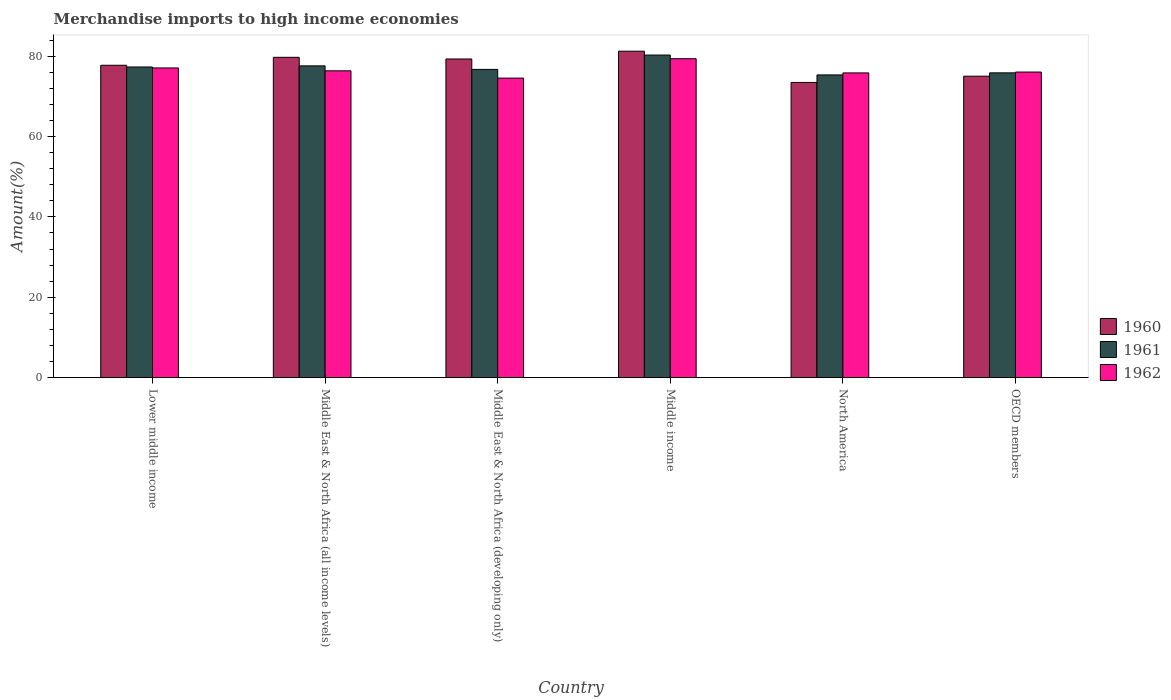How many bars are there on the 3rd tick from the left?
Your answer should be compact. 3. What is the label of the 3rd group of bars from the left?
Make the answer very short. Middle East & North Africa (developing only). In how many cases, is the number of bars for a given country not equal to the number of legend labels?
Your response must be concise. 0. What is the percentage of amount earned from merchandise imports in 1962 in North America?
Make the answer very short. 75.82. Across all countries, what is the maximum percentage of amount earned from merchandise imports in 1961?
Provide a short and direct response. 80.27. Across all countries, what is the minimum percentage of amount earned from merchandise imports in 1960?
Make the answer very short. 73.45. In which country was the percentage of amount earned from merchandise imports in 1960 maximum?
Your answer should be compact. Middle income. What is the total percentage of amount earned from merchandise imports in 1962 in the graph?
Your answer should be compact. 459.16. What is the difference between the percentage of amount earned from merchandise imports in 1961 in Middle East & North Africa (developing only) and that in Middle income?
Your answer should be very brief. -3.57. What is the difference between the percentage of amount earned from merchandise imports in 1962 in OECD members and the percentage of amount earned from merchandise imports in 1960 in Lower middle income?
Keep it short and to the point. -1.69. What is the average percentage of amount earned from merchandise imports in 1962 per country?
Offer a terse response. 76.53. What is the difference between the percentage of amount earned from merchandise imports of/in 1962 and percentage of amount earned from merchandise imports of/in 1961 in Middle income?
Your response must be concise. -0.91. What is the ratio of the percentage of amount earned from merchandise imports in 1962 in Lower middle income to that in Middle East & North Africa (all income levels)?
Offer a very short reply. 1.01. Is the percentage of amount earned from merchandise imports in 1960 in Middle income less than that in North America?
Give a very brief answer. No. Is the difference between the percentage of amount earned from merchandise imports in 1962 in Lower middle income and Middle East & North Africa (developing only) greater than the difference between the percentage of amount earned from merchandise imports in 1961 in Lower middle income and Middle East & North Africa (developing only)?
Offer a terse response. Yes. What is the difference between the highest and the second highest percentage of amount earned from merchandise imports in 1961?
Your response must be concise. 2.97. What is the difference between the highest and the lowest percentage of amount earned from merchandise imports in 1962?
Your response must be concise. 4.83. What does the 1st bar from the left in Middle income represents?
Your response must be concise. 1960. Is it the case that in every country, the sum of the percentage of amount earned from merchandise imports in 1961 and percentage of amount earned from merchandise imports in 1960 is greater than the percentage of amount earned from merchandise imports in 1962?
Ensure brevity in your answer.  Yes. How many countries are there in the graph?
Provide a short and direct response. 6. What is the difference between two consecutive major ticks on the Y-axis?
Your answer should be very brief. 20. Does the graph contain any zero values?
Keep it short and to the point. No. Where does the legend appear in the graph?
Provide a short and direct response. Center right. What is the title of the graph?
Give a very brief answer. Merchandise imports to high income economies. Does "2012" appear as one of the legend labels in the graph?
Your answer should be very brief. No. What is the label or title of the X-axis?
Provide a succinct answer. Country. What is the label or title of the Y-axis?
Keep it short and to the point. Amount(%). What is the Amount(%) in 1960 in Lower middle income?
Provide a succinct answer. 77.73. What is the Amount(%) in 1961 in Lower middle income?
Offer a very short reply. 77.3. What is the Amount(%) in 1962 in Lower middle income?
Your response must be concise. 77.06. What is the Amount(%) of 1960 in Middle East & North Africa (all income levels)?
Keep it short and to the point. 79.7. What is the Amount(%) of 1961 in Middle East & North Africa (all income levels)?
Make the answer very short. 77.58. What is the Amount(%) of 1962 in Middle East & North Africa (all income levels)?
Offer a very short reply. 76.35. What is the Amount(%) of 1960 in Middle East & North Africa (developing only)?
Provide a short and direct response. 79.29. What is the Amount(%) of 1961 in Middle East & North Africa (developing only)?
Your response must be concise. 76.7. What is the Amount(%) in 1962 in Middle East & North Africa (developing only)?
Your answer should be compact. 74.53. What is the Amount(%) in 1960 in Middle income?
Ensure brevity in your answer.  81.23. What is the Amount(%) in 1961 in Middle income?
Give a very brief answer. 80.27. What is the Amount(%) of 1962 in Middle income?
Your response must be concise. 79.36. What is the Amount(%) in 1960 in North America?
Provide a succinct answer. 73.45. What is the Amount(%) in 1961 in North America?
Provide a short and direct response. 75.33. What is the Amount(%) of 1962 in North America?
Provide a short and direct response. 75.82. What is the Amount(%) of 1960 in OECD members?
Offer a very short reply. 75.01. What is the Amount(%) in 1961 in OECD members?
Provide a succinct answer. 75.84. What is the Amount(%) of 1962 in OECD members?
Your response must be concise. 76.04. Across all countries, what is the maximum Amount(%) in 1960?
Keep it short and to the point. 81.23. Across all countries, what is the maximum Amount(%) of 1961?
Keep it short and to the point. 80.27. Across all countries, what is the maximum Amount(%) of 1962?
Ensure brevity in your answer.  79.36. Across all countries, what is the minimum Amount(%) of 1960?
Offer a very short reply. 73.45. Across all countries, what is the minimum Amount(%) of 1961?
Offer a terse response. 75.33. Across all countries, what is the minimum Amount(%) in 1962?
Offer a very short reply. 74.53. What is the total Amount(%) of 1960 in the graph?
Keep it short and to the point. 466.41. What is the total Amount(%) in 1961 in the graph?
Your answer should be compact. 463.01. What is the total Amount(%) in 1962 in the graph?
Make the answer very short. 459.16. What is the difference between the Amount(%) of 1960 in Lower middle income and that in Middle East & North Africa (all income levels)?
Keep it short and to the point. -1.98. What is the difference between the Amount(%) in 1961 in Lower middle income and that in Middle East & North Africa (all income levels)?
Keep it short and to the point. -0.28. What is the difference between the Amount(%) in 1962 in Lower middle income and that in Middle East & North Africa (all income levels)?
Ensure brevity in your answer.  0.72. What is the difference between the Amount(%) of 1960 in Lower middle income and that in Middle East & North Africa (developing only)?
Your response must be concise. -1.57. What is the difference between the Amount(%) of 1961 in Lower middle income and that in Middle East & North Africa (developing only)?
Provide a short and direct response. 0.6. What is the difference between the Amount(%) in 1962 in Lower middle income and that in Middle East & North Africa (developing only)?
Ensure brevity in your answer.  2.53. What is the difference between the Amount(%) of 1960 in Lower middle income and that in Middle income?
Your answer should be very brief. -3.5. What is the difference between the Amount(%) in 1961 in Lower middle income and that in Middle income?
Your response must be concise. -2.97. What is the difference between the Amount(%) in 1962 in Lower middle income and that in Middle income?
Offer a very short reply. -2.3. What is the difference between the Amount(%) in 1960 in Lower middle income and that in North America?
Your response must be concise. 4.27. What is the difference between the Amount(%) in 1961 in Lower middle income and that in North America?
Provide a short and direct response. 1.97. What is the difference between the Amount(%) in 1962 in Lower middle income and that in North America?
Your response must be concise. 1.24. What is the difference between the Amount(%) in 1960 in Lower middle income and that in OECD members?
Offer a terse response. 2.72. What is the difference between the Amount(%) in 1961 in Lower middle income and that in OECD members?
Your response must be concise. 1.46. What is the difference between the Amount(%) of 1962 in Lower middle income and that in OECD members?
Ensure brevity in your answer.  1.02. What is the difference between the Amount(%) in 1960 in Middle East & North Africa (all income levels) and that in Middle East & North Africa (developing only)?
Give a very brief answer. 0.41. What is the difference between the Amount(%) in 1961 in Middle East & North Africa (all income levels) and that in Middle East & North Africa (developing only)?
Your answer should be compact. 0.88. What is the difference between the Amount(%) of 1962 in Middle East & North Africa (all income levels) and that in Middle East & North Africa (developing only)?
Provide a short and direct response. 1.81. What is the difference between the Amount(%) in 1960 in Middle East & North Africa (all income levels) and that in Middle income?
Make the answer very short. -1.52. What is the difference between the Amount(%) in 1961 in Middle East & North Africa (all income levels) and that in Middle income?
Offer a very short reply. -2.69. What is the difference between the Amount(%) of 1962 in Middle East & North Africa (all income levels) and that in Middle income?
Provide a succinct answer. -3.01. What is the difference between the Amount(%) in 1960 in Middle East & North Africa (all income levels) and that in North America?
Your answer should be compact. 6.25. What is the difference between the Amount(%) of 1961 in Middle East & North Africa (all income levels) and that in North America?
Keep it short and to the point. 2.25. What is the difference between the Amount(%) of 1962 in Middle East & North Africa (all income levels) and that in North America?
Ensure brevity in your answer.  0.52. What is the difference between the Amount(%) in 1960 in Middle East & North Africa (all income levels) and that in OECD members?
Give a very brief answer. 4.69. What is the difference between the Amount(%) in 1961 in Middle East & North Africa (all income levels) and that in OECD members?
Give a very brief answer. 1.74. What is the difference between the Amount(%) in 1962 in Middle East & North Africa (all income levels) and that in OECD members?
Give a very brief answer. 0.31. What is the difference between the Amount(%) of 1960 in Middle East & North Africa (developing only) and that in Middle income?
Give a very brief answer. -1.94. What is the difference between the Amount(%) of 1961 in Middle East & North Africa (developing only) and that in Middle income?
Offer a very short reply. -3.57. What is the difference between the Amount(%) of 1962 in Middle East & North Africa (developing only) and that in Middle income?
Make the answer very short. -4.83. What is the difference between the Amount(%) in 1960 in Middle East & North Africa (developing only) and that in North America?
Your response must be concise. 5.84. What is the difference between the Amount(%) in 1961 in Middle East & North Africa (developing only) and that in North America?
Your answer should be compact. 1.37. What is the difference between the Amount(%) of 1962 in Middle East & North Africa (developing only) and that in North America?
Offer a terse response. -1.29. What is the difference between the Amount(%) of 1960 in Middle East & North Africa (developing only) and that in OECD members?
Offer a very short reply. 4.28. What is the difference between the Amount(%) of 1961 in Middle East & North Africa (developing only) and that in OECD members?
Ensure brevity in your answer.  0.86. What is the difference between the Amount(%) in 1962 in Middle East & North Africa (developing only) and that in OECD members?
Make the answer very short. -1.51. What is the difference between the Amount(%) of 1960 in Middle income and that in North America?
Your answer should be compact. 7.77. What is the difference between the Amount(%) in 1961 in Middle income and that in North America?
Offer a very short reply. 4.94. What is the difference between the Amount(%) in 1962 in Middle income and that in North America?
Provide a short and direct response. 3.53. What is the difference between the Amount(%) in 1960 in Middle income and that in OECD members?
Your answer should be very brief. 6.22. What is the difference between the Amount(%) of 1961 in Middle income and that in OECD members?
Keep it short and to the point. 4.43. What is the difference between the Amount(%) of 1962 in Middle income and that in OECD members?
Your answer should be very brief. 3.32. What is the difference between the Amount(%) in 1960 in North America and that in OECD members?
Give a very brief answer. -1.56. What is the difference between the Amount(%) in 1961 in North America and that in OECD members?
Ensure brevity in your answer.  -0.51. What is the difference between the Amount(%) in 1962 in North America and that in OECD members?
Provide a short and direct response. -0.21. What is the difference between the Amount(%) in 1960 in Lower middle income and the Amount(%) in 1961 in Middle East & North Africa (all income levels)?
Provide a succinct answer. 0.15. What is the difference between the Amount(%) of 1960 in Lower middle income and the Amount(%) of 1962 in Middle East & North Africa (all income levels)?
Provide a succinct answer. 1.38. What is the difference between the Amount(%) of 1961 in Lower middle income and the Amount(%) of 1962 in Middle East & North Africa (all income levels)?
Offer a very short reply. 0.95. What is the difference between the Amount(%) of 1960 in Lower middle income and the Amount(%) of 1961 in Middle East & North Africa (developing only)?
Provide a succinct answer. 1.03. What is the difference between the Amount(%) in 1960 in Lower middle income and the Amount(%) in 1962 in Middle East & North Africa (developing only)?
Give a very brief answer. 3.19. What is the difference between the Amount(%) in 1961 in Lower middle income and the Amount(%) in 1962 in Middle East & North Africa (developing only)?
Provide a short and direct response. 2.77. What is the difference between the Amount(%) in 1960 in Lower middle income and the Amount(%) in 1961 in Middle income?
Provide a succinct answer. -2.54. What is the difference between the Amount(%) of 1960 in Lower middle income and the Amount(%) of 1962 in Middle income?
Make the answer very short. -1.63. What is the difference between the Amount(%) of 1961 in Lower middle income and the Amount(%) of 1962 in Middle income?
Offer a very short reply. -2.06. What is the difference between the Amount(%) of 1960 in Lower middle income and the Amount(%) of 1961 in North America?
Your response must be concise. 2.4. What is the difference between the Amount(%) of 1960 in Lower middle income and the Amount(%) of 1962 in North America?
Offer a terse response. 1.9. What is the difference between the Amount(%) in 1961 in Lower middle income and the Amount(%) in 1962 in North America?
Provide a short and direct response. 1.47. What is the difference between the Amount(%) of 1960 in Lower middle income and the Amount(%) of 1961 in OECD members?
Your answer should be compact. 1.89. What is the difference between the Amount(%) in 1960 in Lower middle income and the Amount(%) in 1962 in OECD members?
Your answer should be very brief. 1.69. What is the difference between the Amount(%) of 1961 in Lower middle income and the Amount(%) of 1962 in OECD members?
Provide a short and direct response. 1.26. What is the difference between the Amount(%) of 1960 in Middle East & North Africa (all income levels) and the Amount(%) of 1961 in Middle East & North Africa (developing only)?
Make the answer very short. 3. What is the difference between the Amount(%) of 1960 in Middle East & North Africa (all income levels) and the Amount(%) of 1962 in Middle East & North Africa (developing only)?
Provide a succinct answer. 5.17. What is the difference between the Amount(%) in 1961 in Middle East & North Africa (all income levels) and the Amount(%) in 1962 in Middle East & North Africa (developing only)?
Ensure brevity in your answer.  3.04. What is the difference between the Amount(%) of 1960 in Middle East & North Africa (all income levels) and the Amount(%) of 1961 in Middle income?
Make the answer very short. -0.57. What is the difference between the Amount(%) of 1960 in Middle East & North Africa (all income levels) and the Amount(%) of 1962 in Middle income?
Offer a very short reply. 0.34. What is the difference between the Amount(%) of 1961 in Middle East & North Africa (all income levels) and the Amount(%) of 1962 in Middle income?
Offer a very short reply. -1.78. What is the difference between the Amount(%) in 1960 in Middle East & North Africa (all income levels) and the Amount(%) in 1961 in North America?
Provide a short and direct response. 4.38. What is the difference between the Amount(%) in 1960 in Middle East & North Africa (all income levels) and the Amount(%) in 1962 in North America?
Offer a very short reply. 3.88. What is the difference between the Amount(%) of 1961 in Middle East & North Africa (all income levels) and the Amount(%) of 1962 in North America?
Keep it short and to the point. 1.75. What is the difference between the Amount(%) of 1960 in Middle East & North Africa (all income levels) and the Amount(%) of 1961 in OECD members?
Your answer should be compact. 3.86. What is the difference between the Amount(%) of 1960 in Middle East & North Africa (all income levels) and the Amount(%) of 1962 in OECD members?
Offer a very short reply. 3.67. What is the difference between the Amount(%) in 1961 in Middle East & North Africa (all income levels) and the Amount(%) in 1962 in OECD members?
Offer a very short reply. 1.54. What is the difference between the Amount(%) of 1960 in Middle East & North Africa (developing only) and the Amount(%) of 1961 in Middle income?
Your answer should be very brief. -0.98. What is the difference between the Amount(%) in 1960 in Middle East & North Africa (developing only) and the Amount(%) in 1962 in Middle income?
Ensure brevity in your answer.  -0.07. What is the difference between the Amount(%) in 1961 in Middle East & North Africa (developing only) and the Amount(%) in 1962 in Middle income?
Give a very brief answer. -2.66. What is the difference between the Amount(%) in 1960 in Middle East & North Africa (developing only) and the Amount(%) in 1961 in North America?
Your answer should be very brief. 3.97. What is the difference between the Amount(%) of 1960 in Middle East & North Africa (developing only) and the Amount(%) of 1962 in North America?
Your response must be concise. 3.47. What is the difference between the Amount(%) in 1961 in Middle East & North Africa (developing only) and the Amount(%) in 1962 in North America?
Provide a short and direct response. 0.87. What is the difference between the Amount(%) in 1960 in Middle East & North Africa (developing only) and the Amount(%) in 1961 in OECD members?
Provide a succinct answer. 3.45. What is the difference between the Amount(%) of 1960 in Middle East & North Africa (developing only) and the Amount(%) of 1962 in OECD members?
Keep it short and to the point. 3.25. What is the difference between the Amount(%) in 1961 in Middle East & North Africa (developing only) and the Amount(%) in 1962 in OECD members?
Your answer should be very brief. 0.66. What is the difference between the Amount(%) of 1960 in Middle income and the Amount(%) of 1961 in North America?
Offer a terse response. 5.9. What is the difference between the Amount(%) of 1960 in Middle income and the Amount(%) of 1962 in North America?
Give a very brief answer. 5.4. What is the difference between the Amount(%) in 1961 in Middle income and the Amount(%) in 1962 in North America?
Your answer should be compact. 4.44. What is the difference between the Amount(%) in 1960 in Middle income and the Amount(%) in 1961 in OECD members?
Keep it short and to the point. 5.39. What is the difference between the Amount(%) of 1960 in Middle income and the Amount(%) of 1962 in OECD members?
Offer a very short reply. 5.19. What is the difference between the Amount(%) of 1961 in Middle income and the Amount(%) of 1962 in OECD members?
Provide a succinct answer. 4.23. What is the difference between the Amount(%) of 1960 in North America and the Amount(%) of 1961 in OECD members?
Give a very brief answer. -2.39. What is the difference between the Amount(%) of 1960 in North America and the Amount(%) of 1962 in OECD members?
Ensure brevity in your answer.  -2.58. What is the difference between the Amount(%) in 1961 in North America and the Amount(%) in 1962 in OECD members?
Offer a terse response. -0.71. What is the average Amount(%) in 1960 per country?
Give a very brief answer. 77.74. What is the average Amount(%) in 1961 per country?
Provide a succinct answer. 77.17. What is the average Amount(%) of 1962 per country?
Offer a terse response. 76.53. What is the difference between the Amount(%) in 1960 and Amount(%) in 1961 in Lower middle income?
Provide a succinct answer. 0.43. What is the difference between the Amount(%) of 1960 and Amount(%) of 1962 in Lower middle income?
Make the answer very short. 0.66. What is the difference between the Amount(%) in 1961 and Amount(%) in 1962 in Lower middle income?
Offer a terse response. 0.24. What is the difference between the Amount(%) in 1960 and Amount(%) in 1961 in Middle East & North Africa (all income levels)?
Provide a succinct answer. 2.13. What is the difference between the Amount(%) in 1960 and Amount(%) in 1962 in Middle East & North Africa (all income levels)?
Give a very brief answer. 3.36. What is the difference between the Amount(%) in 1961 and Amount(%) in 1962 in Middle East & North Africa (all income levels)?
Give a very brief answer. 1.23. What is the difference between the Amount(%) of 1960 and Amount(%) of 1961 in Middle East & North Africa (developing only)?
Provide a succinct answer. 2.59. What is the difference between the Amount(%) of 1960 and Amount(%) of 1962 in Middle East & North Africa (developing only)?
Make the answer very short. 4.76. What is the difference between the Amount(%) in 1961 and Amount(%) in 1962 in Middle East & North Africa (developing only)?
Offer a terse response. 2.17. What is the difference between the Amount(%) in 1960 and Amount(%) in 1961 in Middle income?
Your answer should be very brief. 0.96. What is the difference between the Amount(%) in 1960 and Amount(%) in 1962 in Middle income?
Your answer should be compact. 1.87. What is the difference between the Amount(%) of 1961 and Amount(%) of 1962 in Middle income?
Give a very brief answer. 0.91. What is the difference between the Amount(%) in 1960 and Amount(%) in 1961 in North America?
Give a very brief answer. -1.87. What is the difference between the Amount(%) in 1960 and Amount(%) in 1962 in North America?
Provide a short and direct response. -2.37. What is the difference between the Amount(%) in 1961 and Amount(%) in 1962 in North America?
Your response must be concise. -0.5. What is the difference between the Amount(%) in 1960 and Amount(%) in 1961 in OECD members?
Ensure brevity in your answer.  -0.83. What is the difference between the Amount(%) in 1960 and Amount(%) in 1962 in OECD members?
Keep it short and to the point. -1.03. What is the difference between the Amount(%) in 1961 and Amount(%) in 1962 in OECD members?
Your answer should be compact. -0.2. What is the ratio of the Amount(%) in 1960 in Lower middle income to that in Middle East & North Africa (all income levels)?
Ensure brevity in your answer.  0.98. What is the ratio of the Amount(%) of 1961 in Lower middle income to that in Middle East & North Africa (all income levels)?
Offer a terse response. 1. What is the ratio of the Amount(%) of 1962 in Lower middle income to that in Middle East & North Africa (all income levels)?
Offer a terse response. 1.01. What is the ratio of the Amount(%) in 1960 in Lower middle income to that in Middle East & North Africa (developing only)?
Make the answer very short. 0.98. What is the ratio of the Amount(%) in 1961 in Lower middle income to that in Middle East & North Africa (developing only)?
Your response must be concise. 1.01. What is the ratio of the Amount(%) of 1962 in Lower middle income to that in Middle East & North Africa (developing only)?
Provide a short and direct response. 1.03. What is the ratio of the Amount(%) in 1960 in Lower middle income to that in Middle income?
Offer a very short reply. 0.96. What is the ratio of the Amount(%) in 1962 in Lower middle income to that in Middle income?
Provide a succinct answer. 0.97. What is the ratio of the Amount(%) of 1960 in Lower middle income to that in North America?
Give a very brief answer. 1.06. What is the ratio of the Amount(%) of 1961 in Lower middle income to that in North America?
Keep it short and to the point. 1.03. What is the ratio of the Amount(%) in 1962 in Lower middle income to that in North America?
Provide a succinct answer. 1.02. What is the ratio of the Amount(%) of 1960 in Lower middle income to that in OECD members?
Provide a succinct answer. 1.04. What is the ratio of the Amount(%) of 1961 in Lower middle income to that in OECD members?
Make the answer very short. 1.02. What is the ratio of the Amount(%) of 1962 in Lower middle income to that in OECD members?
Your response must be concise. 1.01. What is the ratio of the Amount(%) of 1961 in Middle East & North Africa (all income levels) to that in Middle East & North Africa (developing only)?
Ensure brevity in your answer.  1.01. What is the ratio of the Amount(%) of 1962 in Middle East & North Africa (all income levels) to that in Middle East & North Africa (developing only)?
Offer a terse response. 1.02. What is the ratio of the Amount(%) in 1960 in Middle East & North Africa (all income levels) to that in Middle income?
Keep it short and to the point. 0.98. What is the ratio of the Amount(%) in 1961 in Middle East & North Africa (all income levels) to that in Middle income?
Keep it short and to the point. 0.97. What is the ratio of the Amount(%) in 1960 in Middle East & North Africa (all income levels) to that in North America?
Your answer should be compact. 1.09. What is the ratio of the Amount(%) in 1961 in Middle East & North Africa (all income levels) to that in North America?
Make the answer very short. 1.03. What is the ratio of the Amount(%) in 1960 in Middle East & North Africa (all income levels) to that in OECD members?
Your answer should be very brief. 1.06. What is the ratio of the Amount(%) in 1961 in Middle East & North Africa (all income levels) to that in OECD members?
Your answer should be very brief. 1.02. What is the ratio of the Amount(%) in 1962 in Middle East & North Africa (all income levels) to that in OECD members?
Ensure brevity in your answer.  1. What is the ratio of the Amount(%) in 1960 in Middle East & North Africa (developing only) to that in Middle income?
Your response must be concise. 0.98. What is the ratio of the Amount(%) of 1961 in Middle East & North Africa (developing only) to that in Middle income?
Make the answer very short. 0.96. What is the ratio of the Amount(%) of 1962 in Middle East & North Africa (developing only) to that in Middle income?
Offer a very short reply. 0.94. What is the ratio of the Amount(%) of 1960 in Middle East & North Africa (developing only) to that in North America?
Ensure brevity in your answer.  1.08. What is the ratio of the Amount(%) of 1961 in Middle East & North Africa (developing only) to that in North America?
Provide a succinct answer. 1.02. What is the ratio of the Amount(%) in 1960 in Middle East & North Africa (developing only) to that in OECD members?
Your answer should be very brief. 1.06. What is the ratio of the Amount(%) in 1961 in Middle East & North Africa (developing only) to that in OECD members?
Your answer should be very brief. 1.01. What is the ratio of the Amount(%) of 1962 in Middle East & North Africa (developing only) to that in OECD members?
Offer a terse response. 0.98. What is the ratio of the Amount(%) in 1960 in Middle income to that in North America?
Ensure brevity in your answer.  1.11. What is the ratio of the Amount(%) in 1961 in Middle income to that in North America?
Your answer should be compact. 1.07. What is the ratio of the Amount(%) of 1962 in Middle income to that in North America?
Your answer should be compact. 1.05. What is the ratio of the Amount(%) in 1960 in Middle income to that in OECD members?
Provide a short and direct response. 1.08. What is the ratio of the Amount(%) of 1961 in Middle income to that in OECD members?
Offer a terse response. 1.06. What is the ratio of the Amount(%) in 1962 in Middle income to that in OECD members?
Offer a terse response. 1.04. What is the ratio of the Amount(%) of 1960 in North America to that in OECD members?
Your answer should be very brief. 0.98. What is the ratio of the Amount(%) in 1961 in North America to that in OECD members?
Offer a very short reply. 0.99. What is the difference between the highest and the second highest Amount(%) of 1960?
Provide a succinct answer. 1.52. What is the difference between the highest and the second highest Amount(%) of 1961?
Ensure brevity in your answer.  2.69. What is the difference between the highest and the second highest Amount(%) in 1962?
Offer a very short reply. 2.3. What is the difference between the highest and the lowest Amount(%) of 1960?
Provide a short and direct response. 7.77. What is the difference between the highest and the lowest Amount(%) in 1961?
Provide a short and direct response. 4.94. What is the difference between the highest and the lowest Amount(%) in 1962?
Your answer should be very brief. 4.83. 